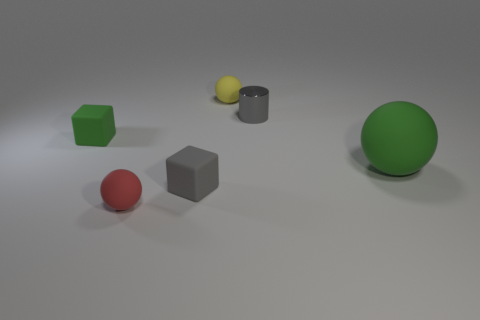Add 4 small red rubber things. How many objects exist? 10 Subtract all cubes. How many objects are left? 4 Subtract all tiny green blocks. Subtract all big brown metallic spheres. How many objects are left? 5 Add 2 large green rubber balls. How many large green rubber balls are left? 3 Add 2 tiny yellow shiny things. How many tiny yellow shiny things exist? 2 Subtract 0 purple cylinders. How many objects are left? 6 